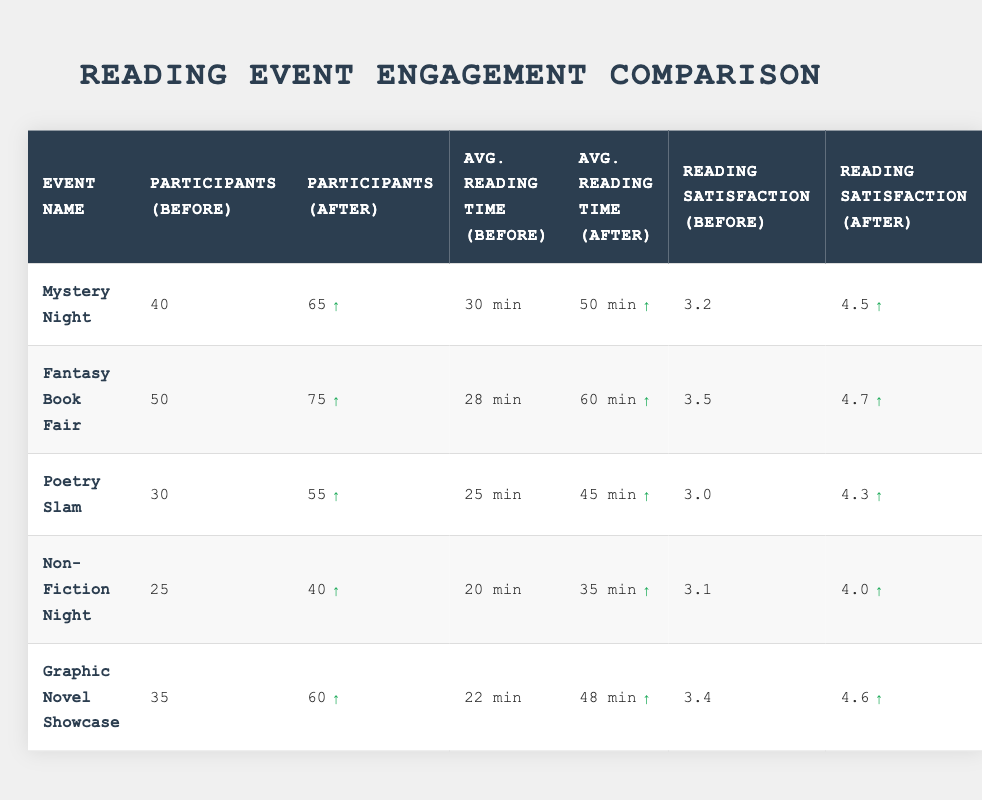What is the total number of participants before all events? To find the total number of participants before all events, we add the participants from each event: 40 + 50 + 30 + 25 + 35 = 180.
Answer: 180 What is the average reading satisfaction before the events? To find the average satisfaction before the events, we add the satisfaction scores before and divide by the number of events: (3.2 + 3.5 + 3.0 + 3.1 + 3.4) / 5 = 3.24.
Answer: 3.24 Which event had the highest increase in average reading time? We calculate the difference in average reading time for each event: Mystery Night (50 - 30 = 20), Fantasy Book Fair (60 - 28 = 32), Poetry Slam (45 - 25 = 20), Non-Fiction Night (35 - 20 = 15), Graphic Novel Showcase (48 - 22 = 26). The highest increase is for Fantasy Book Fair with 32 minutes.
Answer: Fantasy Book Fair Did the participants increase for every event? Yes, we can see that the number of participants increased for all events shown in the table when comparing the before and after numbers.
Answer: Yes What is the difference in reading satisfaction for Mystery Night before and after the event? The difference in reading satisfaction for Mystery Night is calculated by subtracting the before score from the after score: 4.5 - 3.2 = 1.3.
Answer: 1.3 How many more participants attended the Fantasy Book Fair compared to the Non-Fiction Night after the events? The number of participants after the events is compared: Fantasy Book Fair has 75 participants and Non-Fiction Night has 40 participants; the difference is 75 - 40 = 35 participants.
Answer: 35 What was the average reading time after the events across all five events? To determine the average reading time after all events, we sum the average reading times after: 50 + 60 + 45 + 35 + 48 = 238 minutes. Then, we divide by the number of events: 238 / 5 = 47.6 minutes.
Answer: 47.6 Which event saw the lowest average reading satisfaction after the event? After examining the reading satisfaction scores after all events, we see that Non-Fiction Night had the lowest score at 4.0.
Answer: Non-Fiction Night What was the total increase in participants after all events? We first find the total participants after: 65 + 75 + 55 + 40 + 60 = 295. The total before was 180. The increase is 295 - 180 = 115 participants.
Answer: 115 Which reading event had the highest satisfaction rating after the event? By examining the after-satisfaction scores, we see that Fantasy Book Fair had the highest rating of 4.7.
Answer: Fantasy Book Fair 